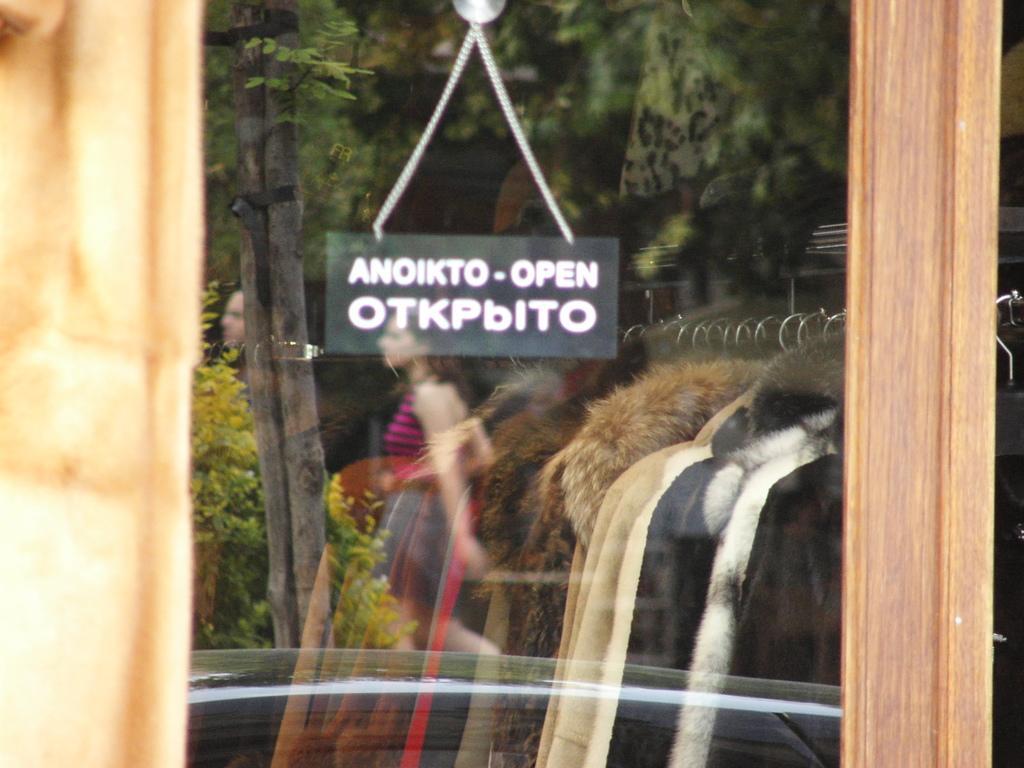In one or two sentences, can you explain what this image depicts? In the center of the image there is a mirror in which there is a reflection of a woman,Trees. There are jackets. To the left side of the image there is a wooden frame. 